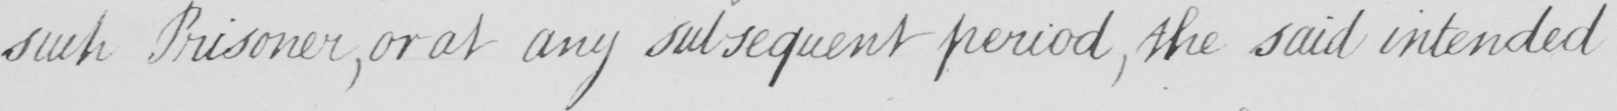What text is written in this handwritten line? such Prisoner , or at any subsequent period , the said intended 